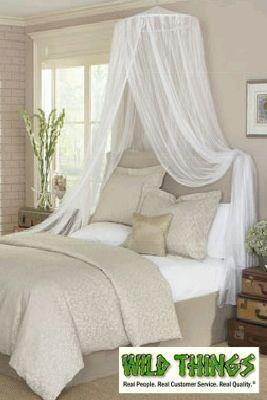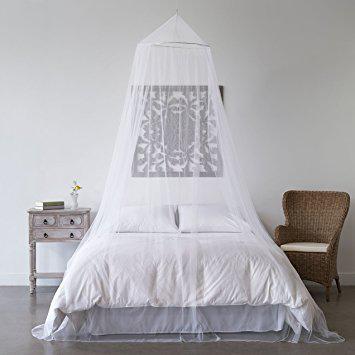The first image is the image on the left, the second image is the image on the right. Examine the images to the left and right. Is the description "All bed drapery is hanging from a central point above a bed." accurate? Answer yes or no. Yes. 